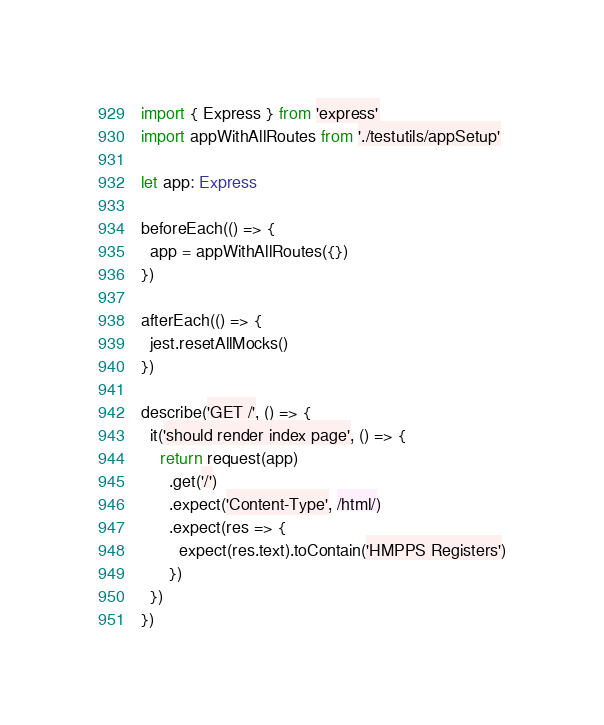Convert code to text. <code><loc_0><loc_0><loc_500><loc_500><_TypeScript_>import { Express } from 'express'
import appWithAllRoutes from './testutils/appSetup'

let app: Express

beforeEach(() => {
  app = appWithAllRoutes({})
})

afterEach(() => {
  jest.resetAllMocks()
})

describe('GET /', () => {
  it('should render index page', () => {
    return request(app)
      .get('/')
      .expect('Content-Type', /html/)
      .expect(res => {
        expect(res.text).toContain('HMPPS Registers')
      })
  })
})
</code> 